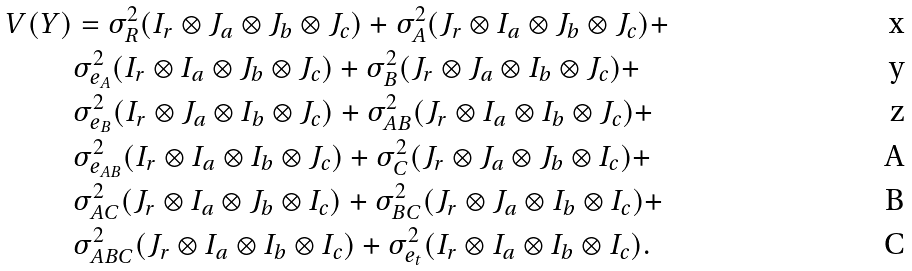<formula> <loc_0><loc_0><loc_500><loc_500>V ( Y ) & = \sigma _ { R } ^ { 2 } ( I _ { r } \otimes J _ { a } \otimes J _ { b } \otimes J _ { c } ) + \sigma _ { A } ^ { 2 } ( J _ { r } \otimes I _ { a } \otimes J _ { b } \otimes J _ { c } ) + \\ & \sigma _ { e _ { A } } ^ { 2 } ( I _ { r } \otimes I _ { a } \otimes J _ { b } \otimes J _ { c } ) + \sigma _ { B } ^ { 2 } ( J _ { r } \otimes J _ { a } \otimes I _ { b } \otimes J _ { c } ) + \\ & \sigma _ { e _ { B } } ^ { 2 } ( I _ { r } \otimes J _ { a } \otimes I _ { b } \otimes J _ { c } ) + \sigma _ { A B } ^ { 2 } ( J _ { r } \otimes I _ { a } \otimes I _ { b } \otimes J _ { c } ) + \\ & \sigma _ { e _ { A B } } ^ { 2 } ( I _ { r } \otimes I _ { a } \otimes I _ { b } \otimes J _ { c } ) + \sigma _ { C } ^ { 2 } ( J _ { r } \otimes J _ { a } \otimes J _ { b } \otimes I _ { c } ) + \\ & \sigma _ { A C } ^ { 2 } ( J _ { r } \otimes I _ { a } \otimes J _ { b } \otimes I _ { c } ) + \sigma _ { B C } ^ { 2 } ( J _ { r } \otimes J _ { a } \otimes I _ { b } \otimes I _ { c } ) + \\ & \sigma _ { A B C } ^ { 2 } ( J _ { r } \otimes I _ { a } \otimes I _ { b } \otimes I _ { c } ) + \sigma _ { e _ { t } } ^ { 2 } ( I _ { r } \otimes I _ { a } \otimes I _ { b } \otimes I _ { c } ) .</formula> 